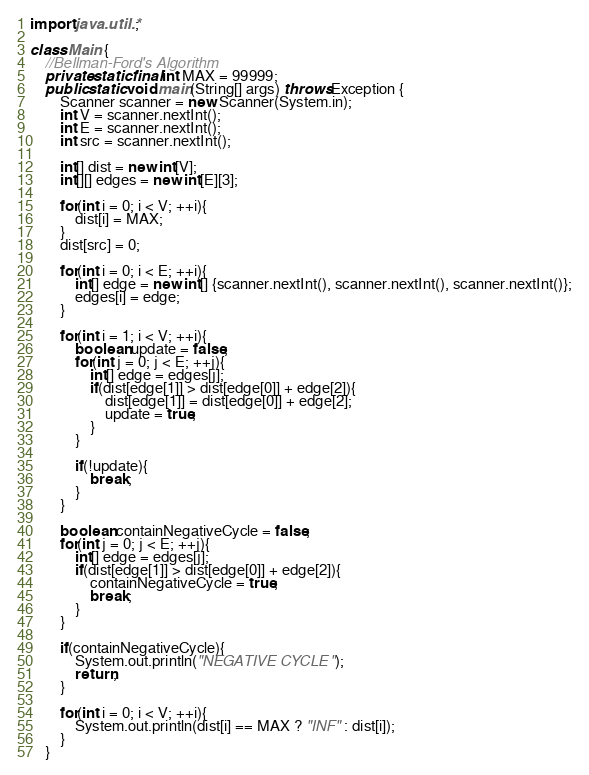<code> <loc_0><loc_0><loc_500><loc_500><_Java_>import java.util.*;

class Main {
    //Bellman-Ford's Algorithm
    private static final int MAX = 99999;
    public static void main(String[] args) throws Exception {
        Scanner scanner = new Scanner(System.in);
        int V = scanner.nextInt();
        int E = scanner.nextInt();
        int src = scanner.nextInt();

        int[] dist = new int[V];
        int[][] edges = new int[E][3];

        for(int i = 0; i < V; ++i){
            dist[i] = MAX;
        }
        dist[src] = 0;

        for(int i = 0; i < E; ++i){
            int[] edge = new int[] {scanner.nextInt(), scanner.nextInt(), scanner.nextInt()};
            edges[i] = edge;
        }

        for(int i = 1; i < V; ++i){
            boolean update = false;
            for(int j = 0; j < E; ++j){
                int[] edge = edges[j];
                if(dist[edge[1]] > dist[edge[0]] + edge[2]){
                    dist[edge[1]] = dist[edge[0]] + edge[2];
                    update = true;
                }
            }

            if(!update){
                break;
            }
        }

        boolean containNegativeCycle = false;
        for(int j = 0; j < E; ++j){
            int[] edge = edges[j];
            if(dist[edge[1]] > dist[edge[0]] + edge[2]){
                containNegativeCycle = true;
                break;
            }
        }

        if(containNegativeCycle){
            System.out.println("NEGATIVE CYCLE");
            return;
        }

        for(int i = 0; i < V; ++i){
            System.out.println(dist[i] == MAX ? "INF" : dist[i]);
        }
    }</code> 